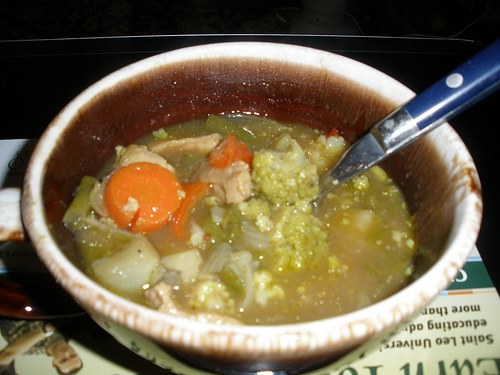On which side is the small potato, the right or the left? The small potato is on the left side of the image. 